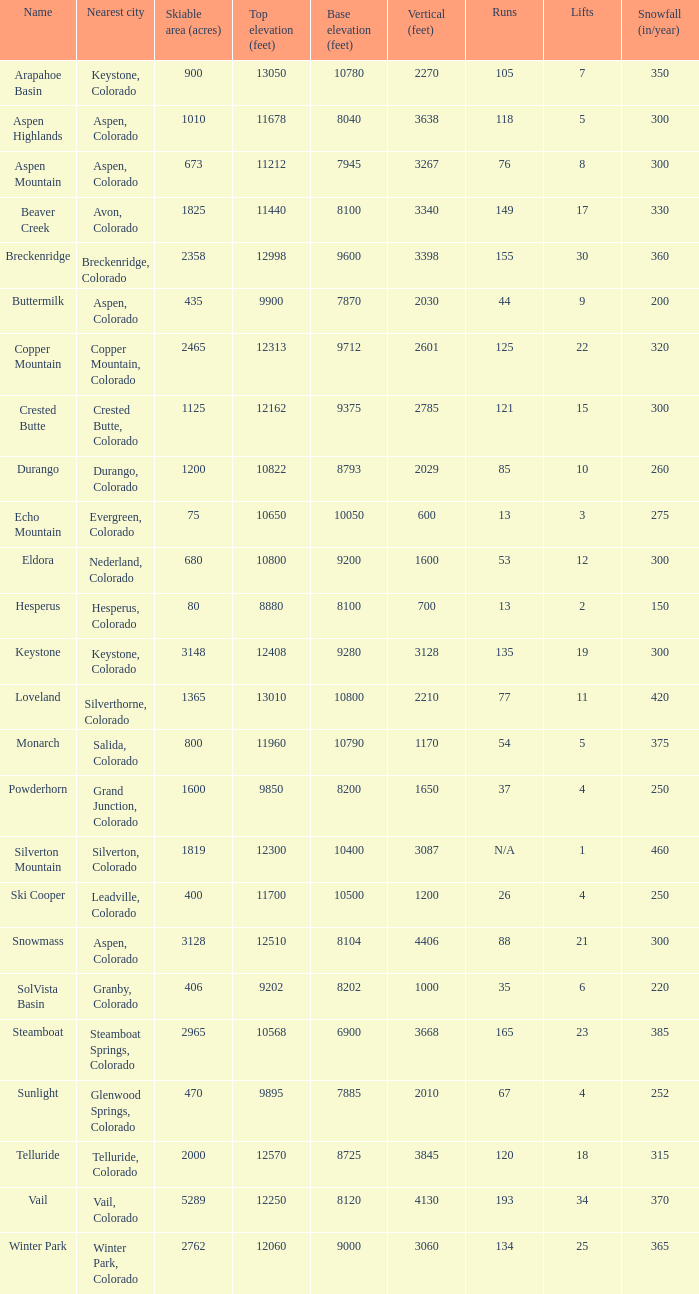What is the snowfall for ski resort Snowmass? 300.0. 